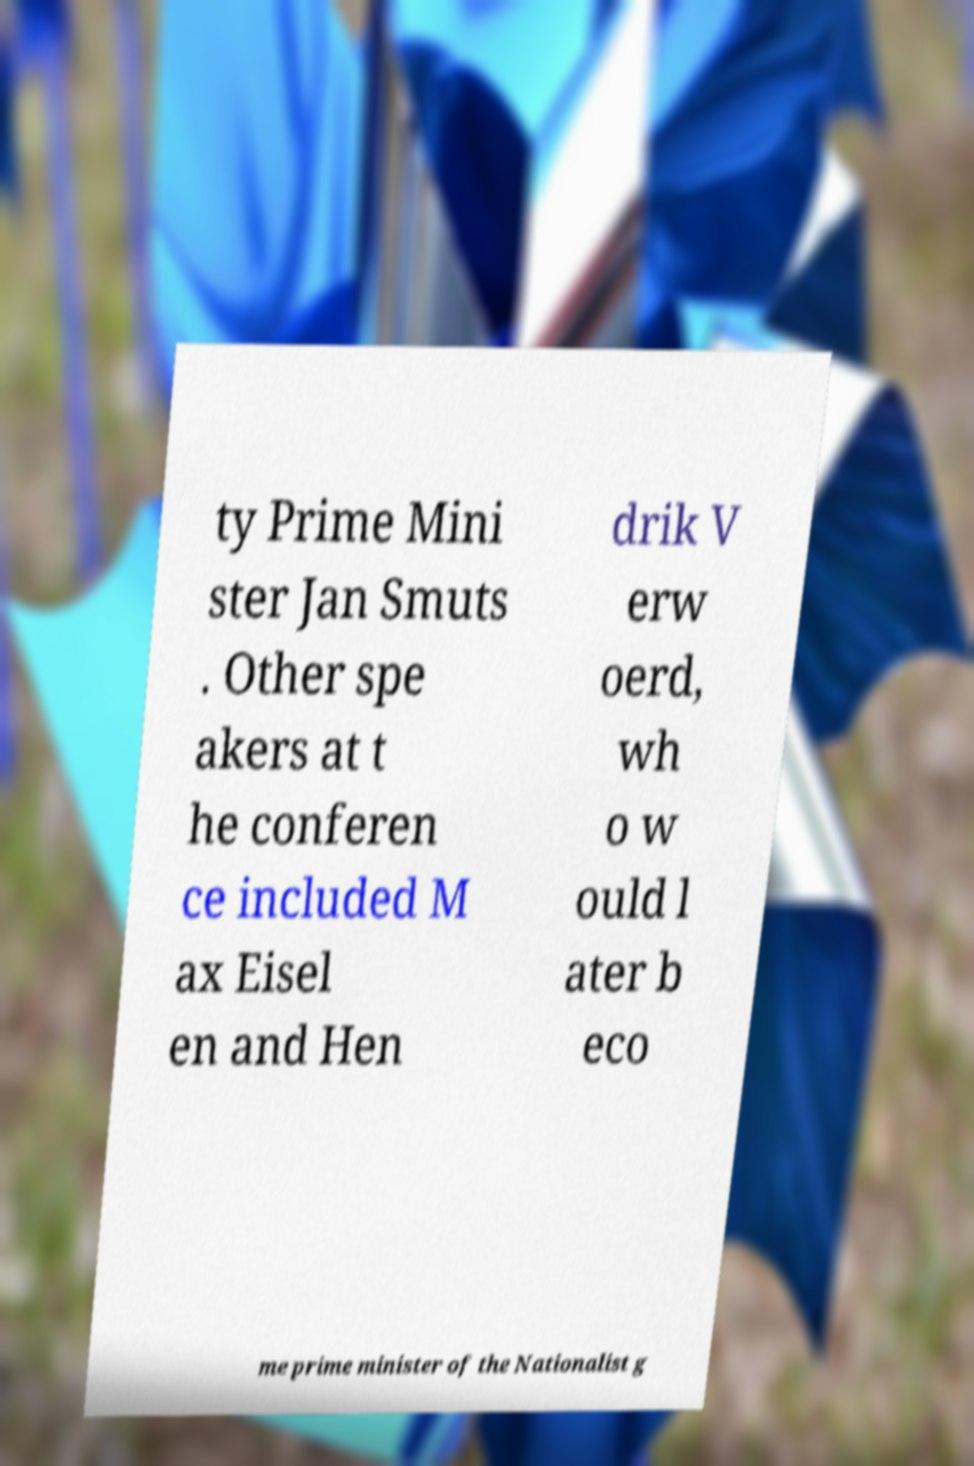Can you accurately transcribe the text from the provided image for me? ty Prime Mini ster Jan Smuts . Other spe akers at t he conferen ce included M ax Eisel en and Hen drik V erw oerd, wh o w ould l ater b eco me prime minister of the Nationalist g 